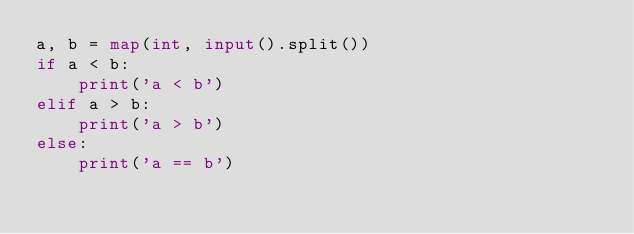<code> <loc_0><loc_0><loc_500><loc_500><_Python_>a, b = map(int, input().split())
if a < b:
    print('a < b')
elif a > b:
    print('a > b')
else:
    print('a == b')

</code> 